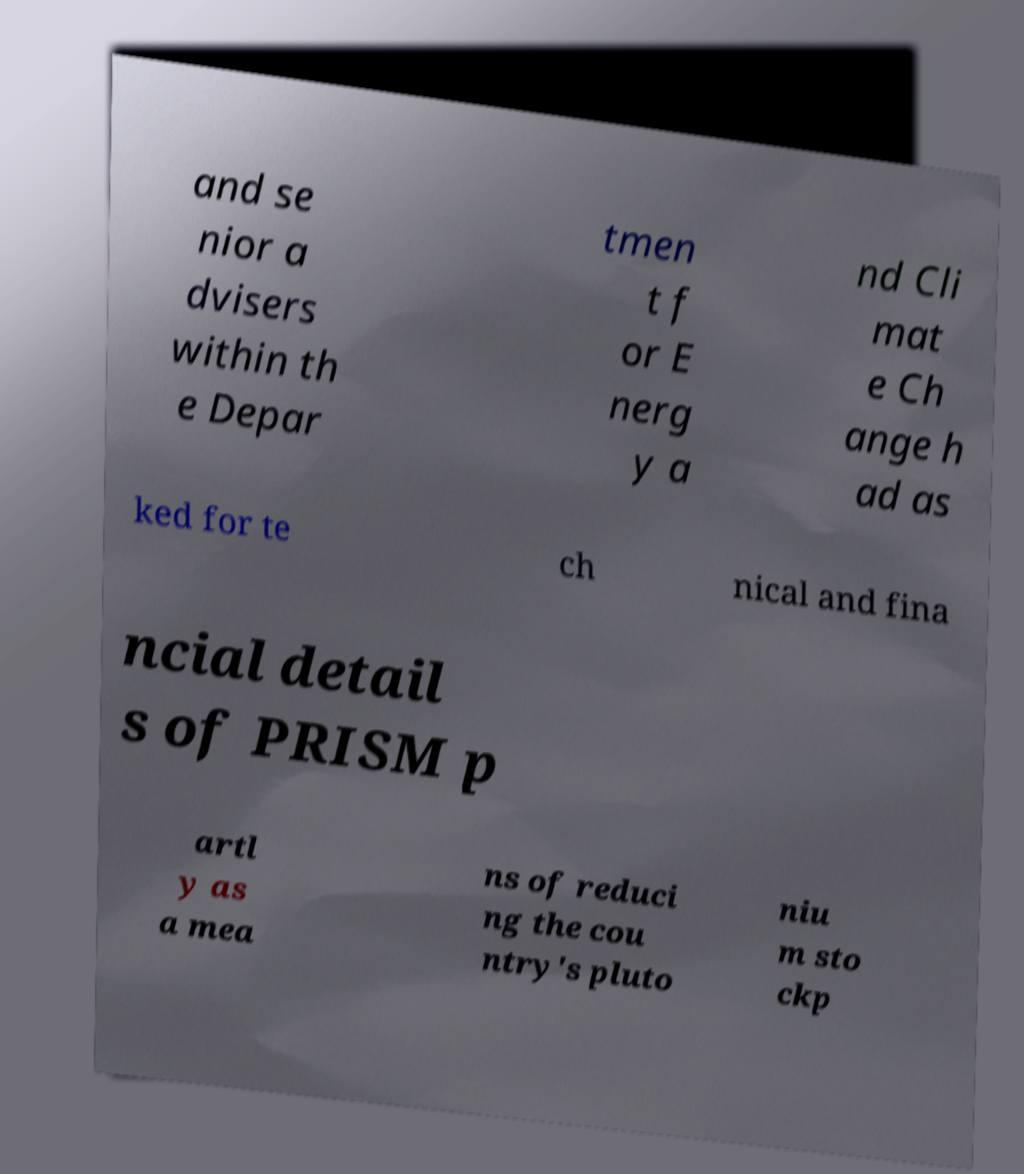Could you extract and type out the text from this image? and se nior a dvisers within th e Depar tmen t f or E nerg y a nd Cli mat e Ch ange h ad as ked for te ch nical and fina ncial detail s of PRISM p artl y as a mea ns of reduci ng the cou ntry's pluto niu m sto ckp 